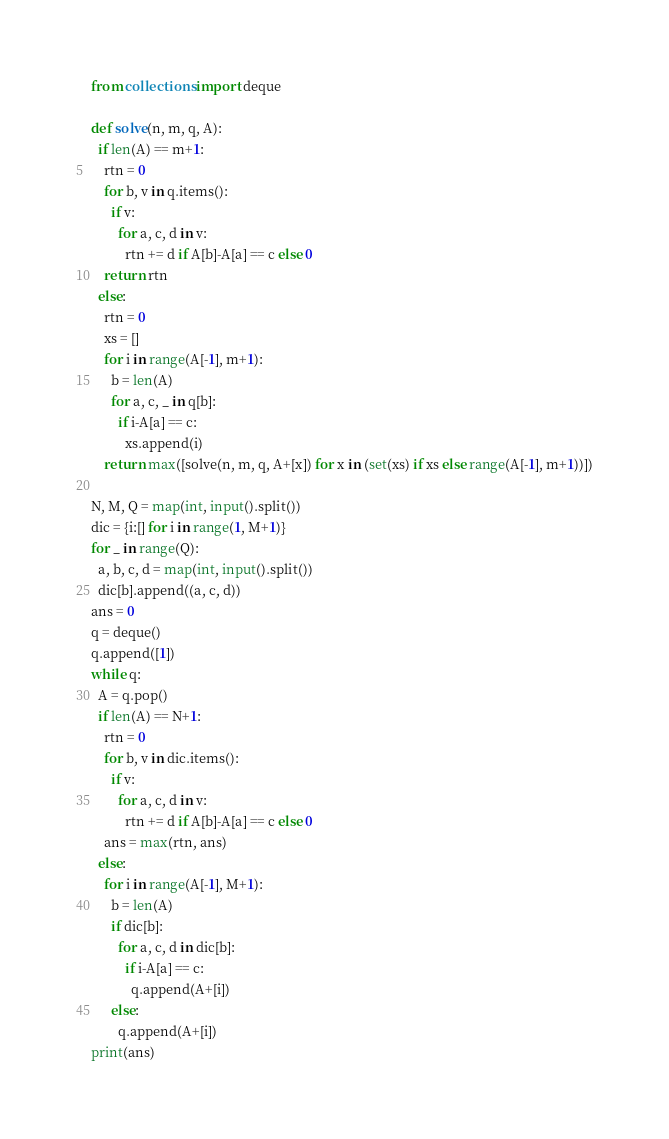Convert code to text. <code><loc_0><loc_0><loc_500><loc_500><_Python_>from collections import deque

def solve(n, m, q, A):
  if len(A) == m+1:
    rtn = 0
    for b, v in q.items():
      if v:
        for a, c, d in v:
          rtn += d if A[b]-A[a] == c else 0
    return rtn
  else:
    rtn = 0
    xs = []
    for i in range(A[-1], m+1):
      b = len(A)
      for a, c, _ in q[b]:
        if i-A[a] == c:
          xs.append(i)
    return max([solve(n, m, q, A+[x]) for x in (set(xs) if xs else range(A[-1], m+1))])

N, M, Q = map(int, input().split())
dic = {i:[] for i in range(1, M+1)}
for _ in range(Q):
  a, b, c, d = map(int, input().split())
  dic[b].append((a, c, d))
ans = 0
q = deque()
q.append([1])
while q:
  A = q.pop()
  if len(A) == N+1:
    rtn = 0
    for b, v in dic.items():
      if v:
        for a, c, d in v:
          rtn += d if A[b]-A[a] == c else 0
    ans = max(rtn, ans)
  else:
    for i in range(A[-1], M+1):
      b = len(A)
      if dic[b]:
        for a, c, d in dic[b]:
          if i-A[a] == c:
            q.append(A+[i])
      else:
        q.append(A+[i])
print(ans)</code> 